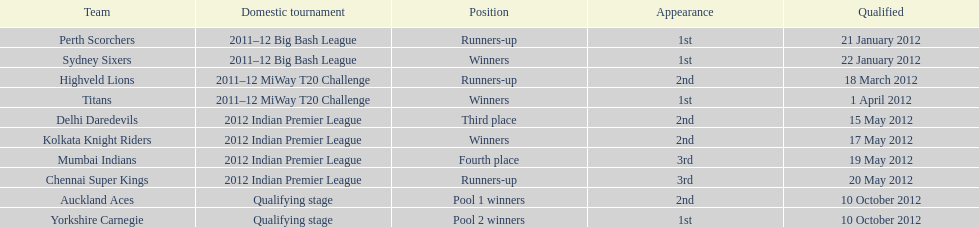Which team debuted in the same competition as the perth scorchers? Sydney Sixers. 